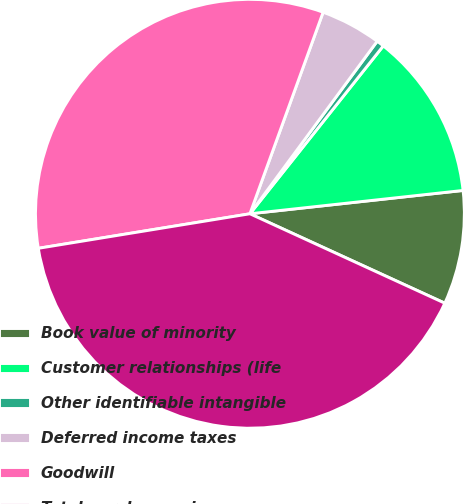<chart> <loc_0><loc_0><loc_500><loc_500><pie_chart><fcel>Book value of minority<fcel>Customer relationships (life<fcel>Other identifiable intangible<fcel>Deferred income taxes<fcel>Goodwill<fcel>Total purchase price<nl><fcel>8.58%<fcel>12.58%<fcel>0.57%<fcel>4.57%<fcel>33.12%<fcel>40.58%<nl></chart> 